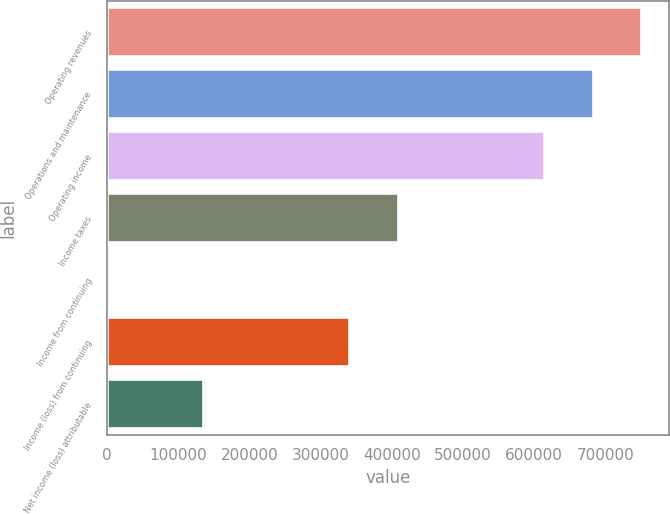Convert chart to OTSL. <chart><loc_0><loc_0><loc_500><loc_500><bar_chart><fcel>Operating revenues<fcel>Operations and maintenance<fcel>Operating income<fcel>Income taxes<fcel>Income from continuing<fcel>Income (loss) from continuing<fcel>Net income (loss) attributable<nl><fcel>751972<fcel>683611<fcel>615250<fcel>410167<fcel>0.06<fcel>341806<fcel>136722<nl></chart> 